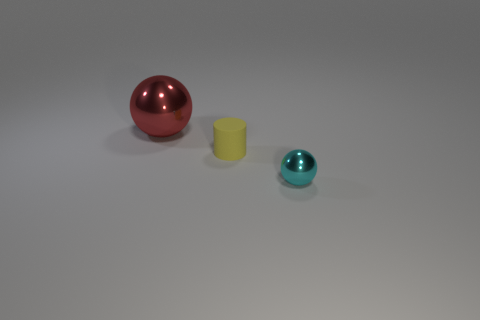Add 3 big purple shiny cylinders. How many objects exist? 6 Subtract all cylinders. How many objects are left? 2 Subtract 0 blue cubes. How many objects are left? 3 Subtract 1 spheres. How many spheres are left? 1 Subtract all yellow balls. Subtract all brown blocks. How many balls are left? 2 Subtract all blue things. Subtract all shiny objects. How many objects are left? 1 Add 1 yellow matte cylinders. How many yellow matte cylinders are left? 2 Add 3 big metallic things. How many big metallic things exist? 4 